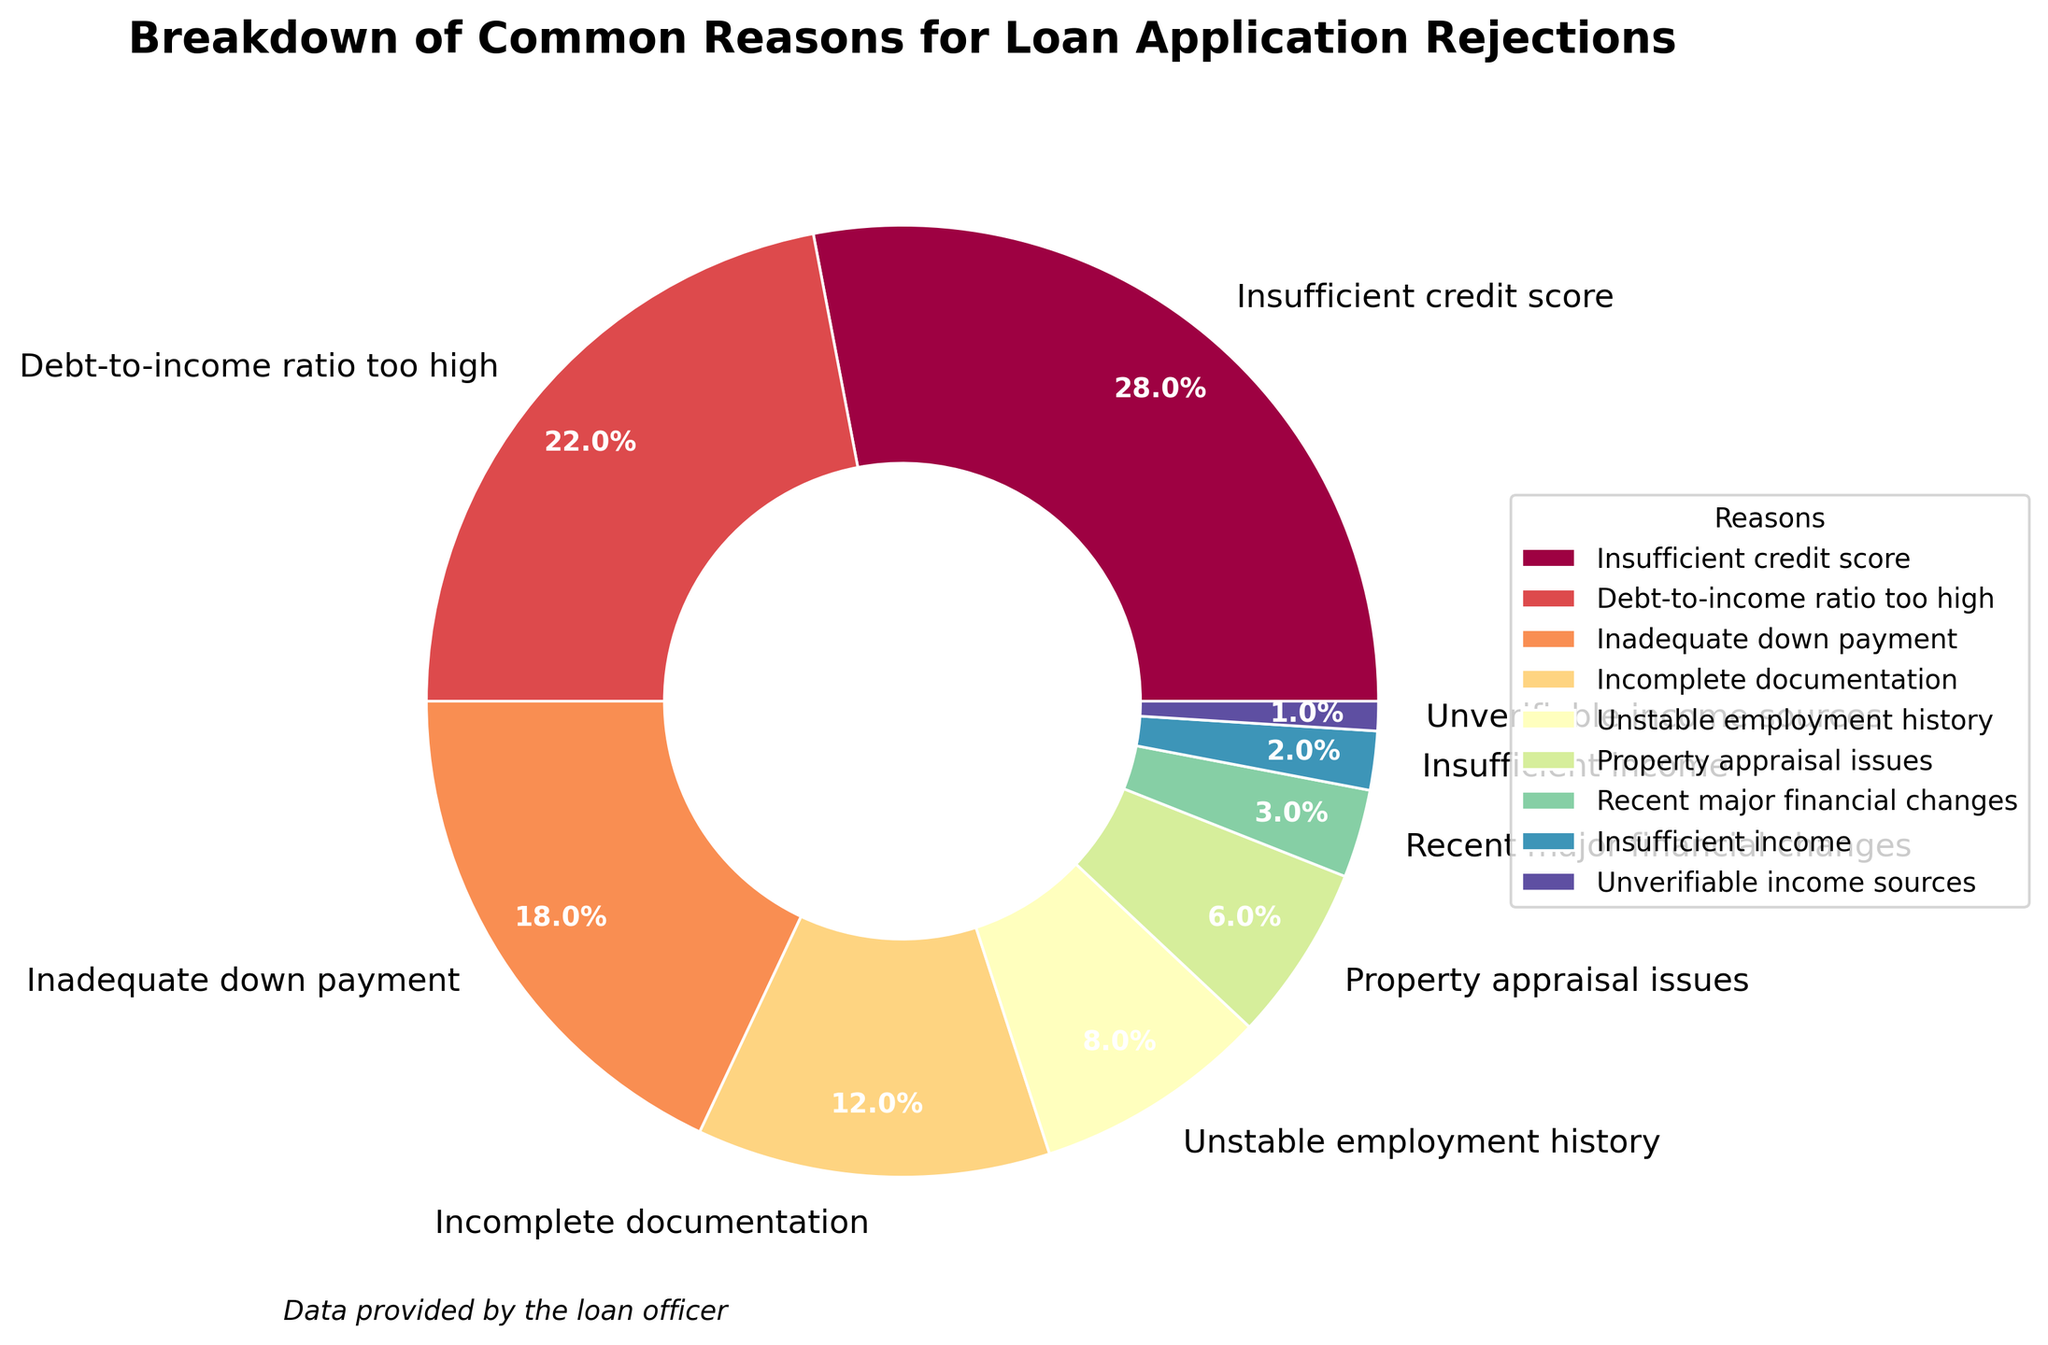What is the most common reason for loan application rejections, and what percentage does it represent? The most common reason can be identified by finding the largest section in the pie chart. The label "Insufficient credit score" corresponds to the largest wedge.
Answer: Insufficient credit score, 28% What is the combined percentage of loan rejections due to unstable employment history and property appraisal issues? Find the percentage values for "Unstable employment history" (8%) and "Property appraisal issues" (6%) from the labels and sum them up: 8% + 6% = 14%
Answer: 14% Which reason has a higher percentage of rejections: inadequate down payment or debt-to-income ratio too high? Observe the wedge sizes for "Inadequate down payment" (18%) and "Debt-to-income ratio too high" (22%) from their labels. Compare the two percentages.
Answer: Debt-to-income ratio too high How much greater is the percentage of rejections due to insufficient income compared to unverifiable income sources? Look at the percentages for "Insufficient income" (2%) and "Unverifiable income sources" (1%) from their labels. Calculate the difference: 2% - 1% = 1%
Answer: 1% What is the total percentage of rejections due to issues related to income (insufficient income and unverifiable income sources)? Identify and sum the percentages for "Insufficient income" and "Unverifiable income sources": 2% + 1% = 3%
Answer: 3% Which section of the pie chart is represented by the color at the farthest end of the color spectrum? The color at the farthest end of the color spectrum, such as violet, is usually used last. The wedge in this color represents "Unverifiable income sources".
Answer: Unverifiable income sources What is the visual difference between the wedges for incomplete documentation and recent major financial changes? The wedge for "Incomplete documentation" is 12%, and "Recent major financial changes" is 3%. "Incomplete documentation" wedge appears larger than "Recent major financial changes".
Answer: Incomplete documentation is larger Is the percentage of rejections due to property appraisal issues closer to that of unstable employment history or recent major financial changes? Compare the percentage for "Property appraisal issues" (6%) with "Unstable employment history" (8%) and "Recent major financial changes" (3%). 6% is closer to 8% than to 3%.
Answer: Unstable employment history What is the second most common reason for loan application rejections? Identify the second-largest wedge in the pie chart, labeled "Debt-to-income ratio too high", which is 22%.
Answer: Debt-to-income ratio too high 